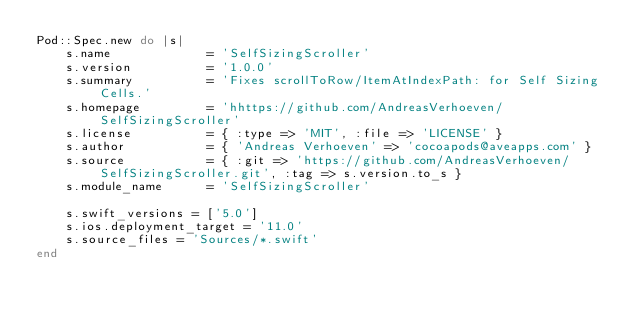Convert code to text. <code><loc_0><loc_0><loc_500><loc_500><_Ruby_>Pod::Spec.new do |s|
    s.name             = 'SelfSizingScroller'
    s.version          = '1.0.0'
    s.summary          = 'Fixes scrollToRow/ItemAtIndexPath: for Self Sizing Cells.'
    s.homepage         = 'hhttps://github.com/AndreasVerhoeven/SelfSizingScroller'
    s.license          = { :type => 'MIT', :file => 'LICENSE' }
    s.author           = { 'Andreas Verhoeven' => 'cocoapods@aveapps.com' }
    s.source           = { :git => 'https://github.com/AndreasVerhoeven/SelfSizingScroller.git', :tag => s.version.to_s }
    s.module_name      = 'SelfSizingScroller'

    s.swift_versions = ['5.0']
    s.ios.deployment_target = '11.0'
    s.source_files = 'Sources/*.swift'
end
</code> 